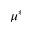Convert formula to latex. <formula><loc_0><loc_0><loc_500><loc_500>\mu ^ { * }</formula> 